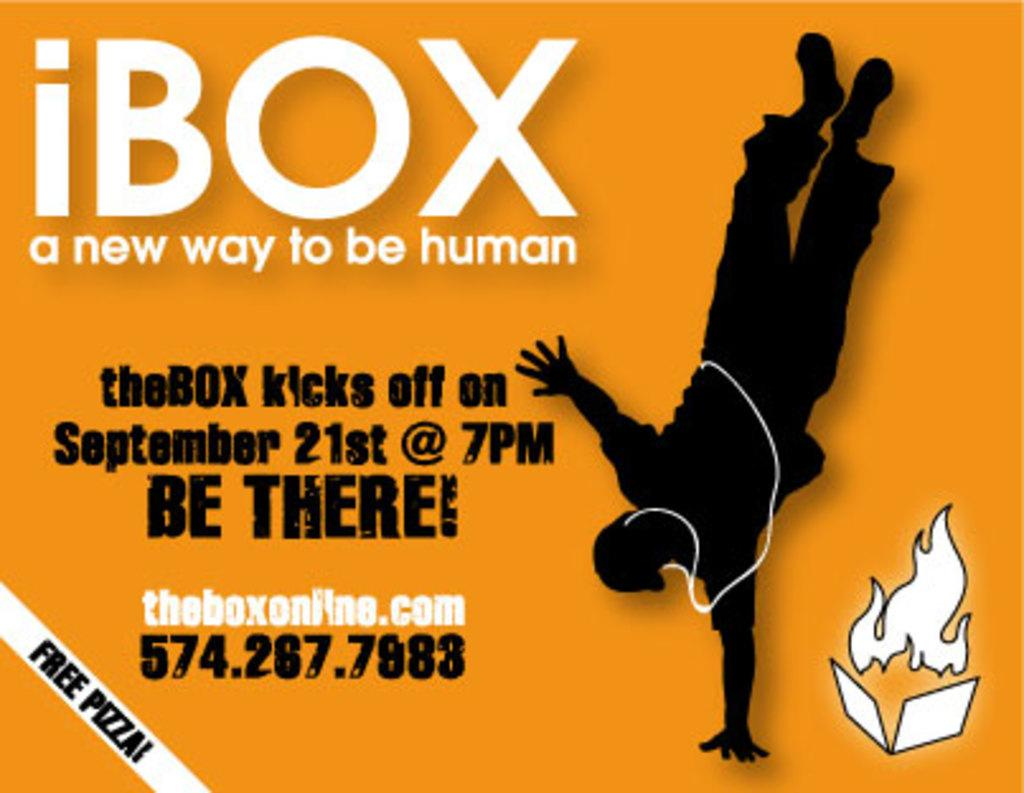Provide a one-sentence caption for the provided image. An event kicks off on September 21st at 7pm. 